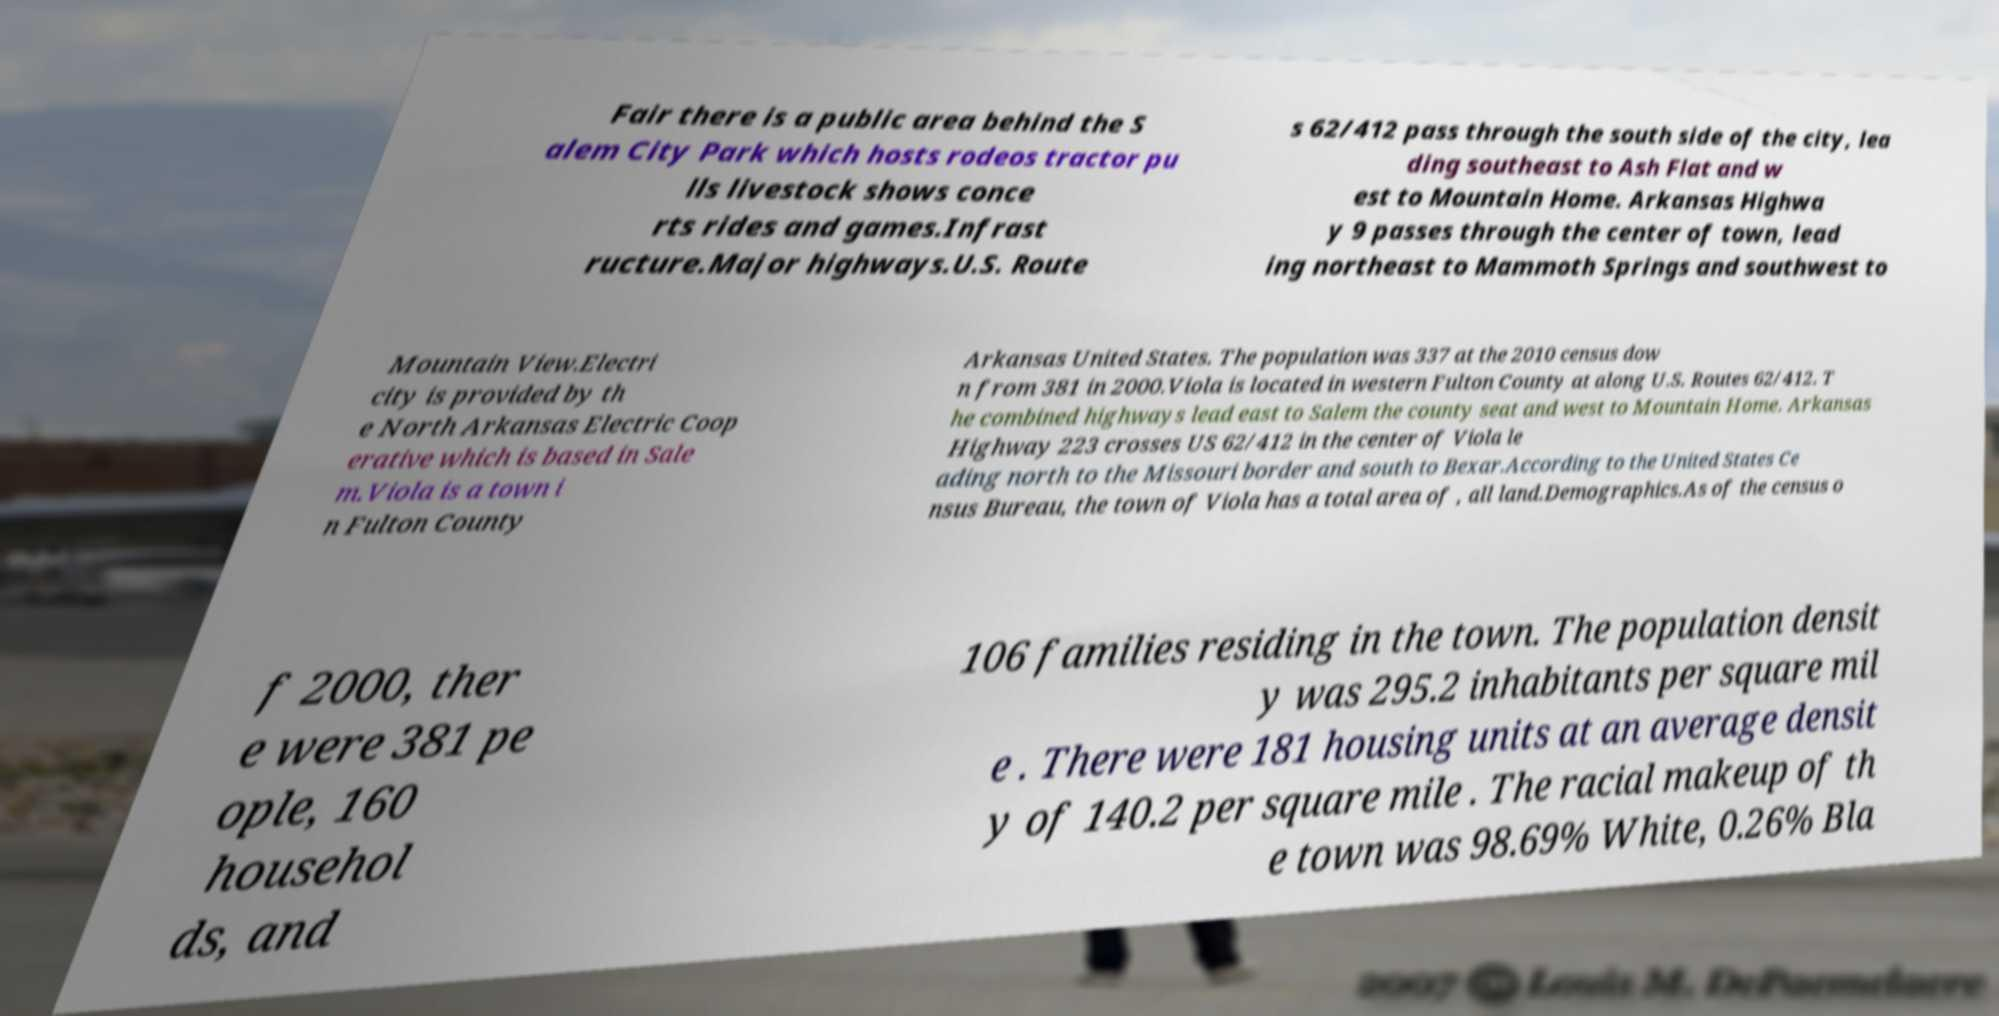What messages or text are displayed in this image? I need them in a readable, typed format. Fair there is a public area behind the S alem City Park which hosts rodeos tractor pu lls livestock shows conce rts rides and games.Infrast ructure.Major highways.U.S. Route s 62/412 pass through the south side of the city, lea ding southeast to Ash Flat and w est to Mountain Home. Arkansas Highwa y 9 passes through the center of town, lead ing northeast to Mammoth Springs and southwest to Mountain View.Electri city is provided by th e North Arkansas Electric Coop erative which is based in Sale m.Viola is a town i n Fulton County Arkansas United States. The population was 337 at the 2010 census dow n from 381 in 2000.Viola is located in western Fulton County at along U.S. Routes 62/412. T he combined highways lead east to Salem the county seat and west to Mountain Home. Arkansas Highway 223 crosses US 62/412 in the center of Viola le ading north to the Missouri border and south to Bexar.According to the United States Ce nsus Bureau, the town of Viola has a total area of , all land.Demographics.As of the census o f 2000, ther e were 381 pe ople, 160 househol ds, and 106 families residing in the town. The population densit y was 295.2 inhabitants per square mil e . There were 181 housing units at an average densit y of 140.2 per square mile . The racial makeup of th e town was 98.69% White, 0.26% Bla 